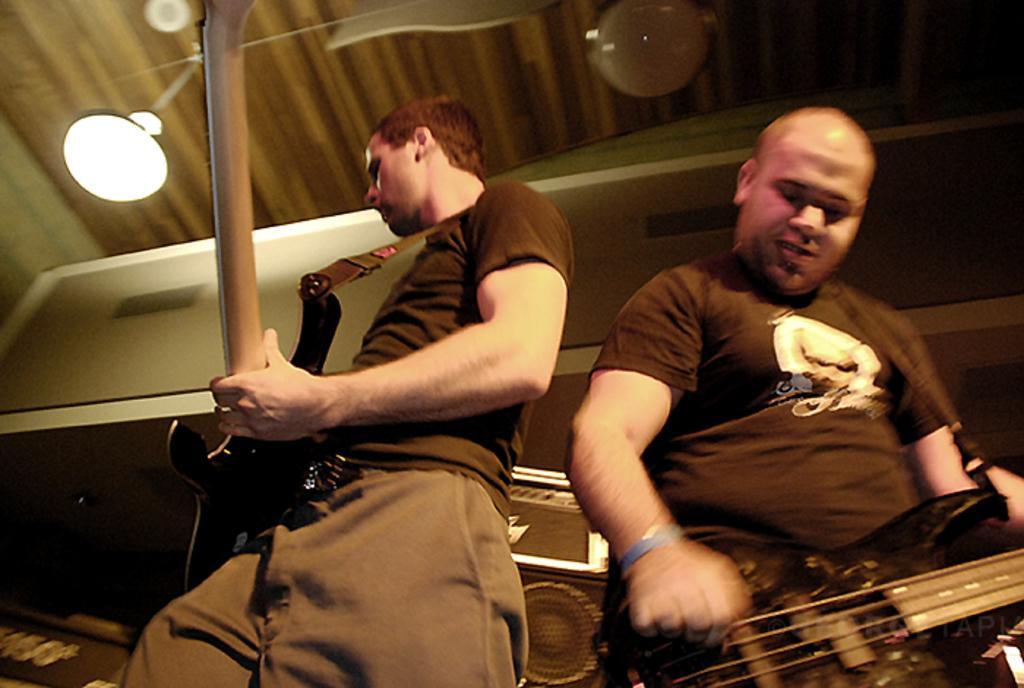Please provide a concise description of this image. These two persons are playing guitar and standing. On top there is a light. Backside of this person there is a speaker and box. 